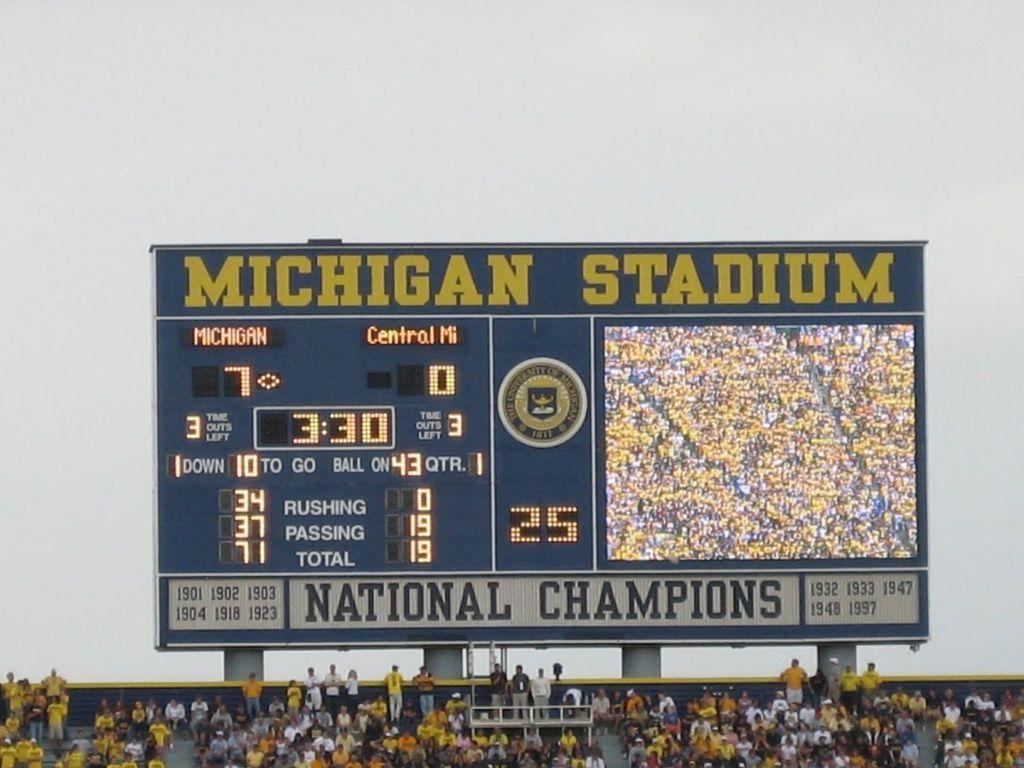<image>
Relay a brief, clear account of the picture shown. The scoreboard at Michigan Stadium is showing the score. 